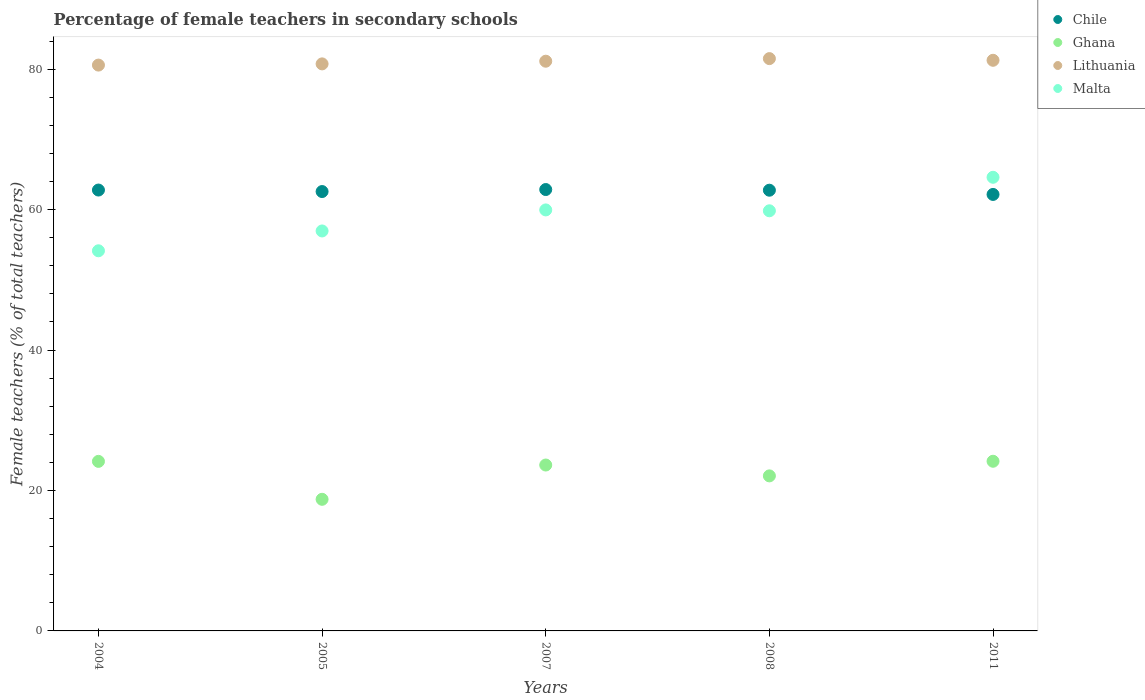How many different coloured dotlines are there?
Make the answer very short. 4. What is the percentage of female teachers in Chile in 2011?
Provide a short and direct response. 62.16. Across all years, what is the maximum percentage of female teachers in Malta?
Your answer should be very brief. 64.6. Across all years, what is the minimum percentage of female teachers in Malta?
Your response must be concise. 54.14. In which year was the percentage of female teachers in Lithuania maximum?
Keep it short and to the point. 2008. What is the total percentage of female teachers in Chile in the graph?
Offer a very short reply. 313.14. What is the difference between the percentage of female teachers in Malta in 2005 and that in 2008?
Your answer should be very brief. -2.87. What is the difference between the percentage of female teachers in Chile in 2005 and the percentage of female teachers in Lithuania in 2008?
Keep it short and to the point. -18.93. What is the average percentage of female teachers in Malta per year?
Make the answer very short. 59.1. In the year 2004, what is the difference between the percentage of female teachers in Ghana and percentage of female teachers in Lithuania?
Give a very brief answer. -56.43. What is the ratio of the percentage of female teachers in Lithuania in 2004 to that in 2008?
Your answer should be very brief. 0.99. Is the percentage of female teachers in Lithuania in 2004 less than that in 2007?
Provide a short and direct response. Yes. Is the difference between the percentage of female teachers in Ghana in 2007 and 2008 greater than the difference between the percentage of female teachers in Lithuania in 2007 and 2008?
Your answer should be compact. Yes. What is the difference between the highest and the second highest percentage of female teachers in Chile?
Provide a succinct answer. 0.07. What is the difference between the highest and the lowest percentage of female teachers in Chile?
Provide a succinct answer. 0.7. Is it the case that in every year, the sum of the percentage of female teachers in Malta and percentage of female teachers in Chile  is greater than the sum of percentage of female teachers in Ghana and percentage of female teachers in Lithuania?
Offer a very short reply. No. Is it the case that in every year, the sum of the percentage of female teachers in Chile and percentage of female teachers in Ghana  is greater than the percentage of female teachers in Lithuania?
Provide a succinct answer. Yes. Does the percentage of female teachers in Chile monotonically increase over the years?
Your answer should be compact. No. Is the percentage of female teachers in Chile strictly greater than the percentage of female teachers in Malta over the years?
Ensure brevity in your answer.  No. How many years are there in the graph?
Offer a very short reply. 5. Does the graph contain any zero values?
Offer a very short reply. No. Does the graph contain grids?
Offer a terse response. No. What is the title of the graph?
Keep it short and to the point. Percentage of female teachers in secondary schools. What is the label or title of the Y-axis?
Your answer should be compact. Female teachers (% of total teachers). What is the Female teachers (% of total teachers) in Chile in 2004?
Your response must be concise. 62.79. What is the Female teachers (% of total teachers) in Ghana in 2004?
Provide a succinct answer. 24.15. What is the Female teachers (% of total teachers) of Lithuania in 2004?
Keep it short and to the point. 80.58. What is the Female teachers (% of total teachers) of Malta in 2004?
Your answer should be compact. 54.14. What is the Female teachers (% of total teachers) of Chile in 2005?
Your response must be concise. 62.57. What is the Female teachers (% of total teachers) in Ghana in 2005?
Keep it short and to the point. 18.74. What is the Female teachers (% of total teachers) in Lithuania in 2005?
Your answer should be very brief. 80.75. What is the Female teachers (% of total teachers) of Malta in 2005?
Your response must be concise. 56.96. What is the Female teachers (% of total teachers) of Chile in 2007?
Ensure brevity in your answer.  62.86. What is the Female teachers (% of total teachers) in Ghana in 2007?
Provide a short and direct response. 23.63. What is the Female teachers (% of total teachers) in Lithuania in 2007?
Your answer should be compact. 81.13. What is the Female teachers (% of total teachers) of Malta in 2007?
Keep it short and to the point. 59.95. What is the Female teachers (% of total teachers) in Chile in 2008?
Give a very brief answer. 62.76. What is the Female teachers (% of total teachers) of Ghana in 2008?
Give a very brief answer. 22.08. What is the Female teachers (% of total teachers) of Lithuania in 2008?
Provide a succinct answer. 81.5. What is the Female teachers (% of total teachers) in Malta in 2008?
Provide a short and direct response. 59.83. What is the Female teachers (% of total teachers) of Chile in 2011?
Make the answer very short. 62.16. What is the Female teachers (% of total teachers) of Ghana in 2011?
Ensure brevity in your answer.  24.16. What is the Female teachers (% of total teachers) in Lithuania in 2011?
Your answer should be very brief. 81.26. What is the Female teachers (% of total teachers) in Malta in 2011?
Your response must be concise. 64.6. Across all years, what is the maximum Female teachers (% of total teachers) of Chile?
Offer a terse response. 62.86. Across all years, what is the maximum Female teachers (% of total teachers) in Ghana?
Provide a succinct answer. 24.16. Across all years, what is the maximum Female teachers (% of total teachers) in Lithuania?
Ensure brevity in your answer.  81.5. Across all years, what is the maximum Female teachers (% of total teachers) of Malta?
Your answer should be very brief. 64.6. Across all years, what is the minimum Female teachers (% of total teachers) in Chile?
Your response must be concise. 62.16. Across all years, what is the minimum Female teachers (% of total teachers) in Ghana?
Offer a very short reply. 18.74. Across all years, what is the minimum Female teachers (% of total teachers) of Lithuania?
Provide a succinct answer. 80.58. Across all years, what is the minimum Female teachers (% of total teachers) in Malta?
Ensure brevity in your answer.  54.14. What is the total Female teachers (% of total teachers) in Chile in the graph?
Make the answer very short. 313.14. What is the total Female teachers (% of total teachers) in Ghana in the graph?
Your answer should be compact. 112.76. What is the total Female teachers (% of total teachers) of Lithuania in the graph?
Provide a succinct answer. 405.23. What is the total Female teachers (% of total teachers) of Malta in the graph?
Provide a short and direct response. 295.48. What is the difference between the Female teachers (% of total teachers) in Chile in 2004 and that in 2005?
Provide a short and direct response. 0.21. What is the difference between the Female teachers (% of total teachers) in Ghana in 2004 and that in 2005?
Ensure brevity in your answer.  5.4. What is the difference between the Female teachers (% of total teachers) in Lithuania in 2004 and that in 2005?
Provide a short and direct response. -0.17. What is the difference between the Female teachers (% of total teachers) in Malta in 2004 and that in 2005?
Your answer should be compact. -2.82. What is the difference between the Female teachers (% of total teachers) in Chile in 2004 and that in 2007?
Your answer should be compact. -0.07. What is the difference between the Female teachers (% of total teachers) in Ghana in 2004 and that in 2007?
Offer a very short reply. 0.52. What is the difference between the Female teachers (% of total teachers) in Lithuania in 2004 and that in 2007?
Your response must be concise. -0.55. What is the difference between the Female teachers (% of total teachers) in Malta in 2004 and that in 2007?
Keep it short and to the point. -5.82. What is the difference between the Female teachers (% of total teachers) in Chile in 2004 and that in 2008?
Offer a terse response. 0.02. What is the difference between the Female teachers (% of total teachers) of Ghana in 2004 and that in 2008?
Provide a short and direct response. 2.07. What is the difference between the Female teachers (% of total teachers) of Lithuania in 2004 and that in 2008?
Provide a short and direct response. -0.92. What is the difference between the Female teachers (% of total teachers) of Malta in 2004 and that in 2008?
Make the answer very short. -5.7. What is the difference between the Female teachers (% of total teachers) in Chile in 2004 and that in 2011?
Give a very brief answer. 0.63. What is the difference between the Female teachers (% of total teachers) in Ghana in 2004 and that in 2011?
Provide a short and direct response. -0.02. What is the difference between the Female teachers (% of total teachers) of Lithuania in 2004 and that in 2011?
Your answer should be compact. -0.68. What is the difference between the Female teachers (% of total teachers) in Malta in 2004 and that in 2011?
Offer a very short reply. -10.47. What is the difference between the Female teachers (% of total teachers) in Chile in 2005 and that in 2007?
Your answer should be very brief. -0.29. What is the difference between the Female teachers (% of total teachers) in Ghana in 2005 and that in 2007?
Offer a terse response. -4.88. What is the difference between the Female teachers (% of total teachers) of Lithuania in 2005 and that in 2007?
Offer a terse response. -0.38. What is the difference between the Female teachers (% of total teachers) of Malta in 2005 and that in 2007?
Your response must be concise. -3. What is the difference between the Female teachers (% of total teachers) of Chile in 2005 and that in 2008?
Keep it short and to the point. -0.19. What is the difference between the Female teachers (% of total teachers) of Ghana in 2005 and that in 2008?
Your answer should be very brief. -3.34. What is the difference between the Female teachers (% of total teachers) of Lithuania in 2005 and that in 2008?
Keep it short and to the point. -0.75. What is the difference between the Female teachers (% of total teachers) in Malta in 2005 and that in 2008?
Make the answer very short. -2.87. What is the difference between the Female teachers (% of total teachers) of Chile in 2005 and that in 2011?
Offer a very short reply. 0.41. What is the difference between the Female teachers (% of total teachers) of Ghana in 2005 and that in 2011?
Make the answer very short. -5.42. What is the difference between the Female teachers (% of total teachers) of Lithuania in 2005 and that in 2011?
Your response must be concise. -0.51. What is the difference between the Female teachers (% of total teachers) of Malta in 2005 and that in 2011?
Offer a terse response. -7.64. What is the difference between the Female teachers (% of total teachers) of Chile in 2007 and that in 2008?
Keep it short and to the point. 0.1. What is the difference between the Female teachers (% of total teachers) in Ghana in 2007 and that in 2008?
Provide a short and direct response. 1.55. What is the difference between the Female teachers (% of total teachers) in Lithuania in 2007 and that in 2008?
Ensure brevity in your answer.  -0.37. What is the difference between the Female teachers (% of total teachers) in Malta in 2007 and that in 2008?
Ensure brevity in your answer.  0.12. What is the difference between the Female teachers (% of total teachers) of Chile in 2007 and that in 2011?
Give a very brief answer. 0.7. What is the difference between the Female teachers (% of total teachers) of Ghana in 2007 and that in 2011?
Your response must be concise. -0.54. What is the difference between the Female teachers (% of total teachers) of Lithuania in 2007 and that in 2011?
Your answer should be compact. -0.13. What is the difference between the Female teachers (% of total teachers) in Malta in 2007 and that in 2011?
Your answer should be compact. -4.65. What is the difference between the Female teachers (% of total teachers) in Chile in 2008 and that in 2011?
Keep it short and to the point. 0.6. What is the difference between the Female teachers (% of total teachers) in Ghana in 2008 and that in 2011?
Provide a short and direct response. -2.08. What is the difference between the Female teachers (% of total teachers) of Lithuania in 2008 and that in 2011?
Your response must be concise. 0.24. What is the difference between the Female teachers (% of total teachers) of Malta in 2008 and that in 2011?
Your response must be concise. -4.77. What is the difference between the Female teachers (% of total teachers) in Chile in 2004 and the Female teachers (% of total teachers) in Ghana in 2005?
Keep it short and to the point. 44.04. What is the difference between the Female teachers (% of total teachers) in Chile in 2004 and the Female teachers (% of total teachers) in Lithuania in 2005?
Your answer should be very brief. -17.97. What is the difference between the Female teachers (% of total teachers) of Chile in 2004 and the Female teachers (% of total teachers) of Malta in 2005?
Offer a terse response. 5.83. What is the difference between the Female teachers (% of total teachers) in Ghana in 2004 and the Female teachers (% of total teachers) in Lithuania in 2005?
Offer a very short reply. -56.61. What is the difference between the Female teachers (% of total teachers) of Ghana in 2004 and the Female teachers (% of total teachers) of Malta in 2005?
Give a very brief answer. -32.81. What is the difference between the Female teachers (% of total teachers) in Lithuania in 2004 and the Female teachers (% of total teachers) in Malta in 2005?
Give a very brief answer. 23.62. What is the difference between the Female teachers (% of total teachers) in Chile in 2004 and the Female teachers (% of total teachers) in Ghana in 2007?
Your answer should be compact. 39.16. What is the difference between the Female teachers (% of total teachers) of Chile in 2004 and the Female teachers (% of total teachers) of Lithuania in 2007?
Keep it short and to the point. -18.35. What is the difference between the Female teachers (% of total teachers) in Chile in 2004 and the Female teachers (% of total teachers) in Malta in 2007?
Ensure brevity in your answer.  2.83. What is the difference between the Female teachers (% of total teachers) of Ghana in 2004 and the Female teachers (% of total teachers) of Lithuania in 2007?
Keep it short and to the point. -56.99. What is the difference between the Female teachers (% of total teachers) in Ghana in 2004 and the Female teachers (% of total teachers) in Malta in 2007?
Offer a very short reply. -35.81. What is the difference between the Female teachers (% of total teachers) of Lithuania in 2004 and the Female teachers (% of total teachers) of Malta in 2007?
Make the answer very short. 20.63. What is the difference between the Female teachers (% of total teachers) in Chile in 2004 and the Female teachers (% of total teachers) in Ghana in 2008?
Ensure brevity in your answer.  40.71. What is the difference between the Female teachers (% of total teachers) in Chile in 2004 and the Female teachers (% of total teachers) in Lithuania in 2008?
Provide a succinct answer. -18.72. What is the difference between the Female teachers (% of total teachers) in Chile in 2004 and the Female teachers (% of total teachers) in Malta in 2008?
Your response must be concise. 2.95. What is the difference between the Female teachers (% of total teachers) in Ghana in 2004 and the Female teachers (% of total teachers) in Lithuania in 2008?
Your answer should be compact. -57.36. What is the difference between the Female teachers (% of total teachers) in Ghana in 2004 and the Female teachers (% of total teachers) in Malta in 2008?
Offer a very short reply. -35.69. What is the difference between the Female teachers (% of total teachers) of Lithuania in 2004 and the Female teachers (% of total teachers) of Malta in 2008?
Offer a very short reply. 20.75. What is the difference between the Female teachers (% of total teachers) of Chile in 2004 and the Female teachers (% of total teachers) of Ghana in 2011?
Provide a succinct answer. 38.62. What is the difference between the Female teachers (% of total teachers) in Chile in 2004 and the Female teachers (% of total teachers) in Lithuania in 2011?
Offer a terse response. -18.48. What is the difference between the Female teachers (% of total teachers) in Chile in 2004 and the Female teachers (% of total teachers) in Malta in 2011?
Provide a short and direct response. -1.82. What is the difference between the Female teachers (% of total teachers) of Ghana in 2004 and the Female teachers (% of total teachers) of Lithuania in 2011?
Make the answer very short. -57.12. What is the difference between the Female teachers (% of total teachers) in Ghana in 2004 and the Female teachers (% of total teachers) in Malta in 2011?
Ensure brevity in your answer.  -40.46. What is the difference between the Female teachers (% of total teachers) in Lithuania in 2004 and the Female teachers (% of total teachers) in Malta in 2011?
Offer a terse response. 15.98. What is the difference between the Female teachers (% of total teachers) in Chile in 2005 and the Female teachers (% of total teachers) in Ghana in 2007?
Your answer should be compact. 38.95. What is the difference between the Female teachers (% of total teachers) in Chile in 2005 and the Female teachers (% of total teachers) in Lithuania in 2007?
Keep it short and to the point. -18.56. What is the difference between the Female teachers (% of total teachers) of Chile in 2005 and the Female teachers (% of total teachers) of Malta in 2007?
Keep it short and to the point. 2.62. What is the difference between the Female teachers (% of total teachers) in Ghana in 2005 and the Female teachers (% of total teachers) in Lithuania in 2007?
Provide a short and direct response. -62.39. What is the difference between the Female teachers (% of total teachers) in Ghana in 2005 and the Female teachers (% of total teachers) in Malta in 2007?
Offer a very short reply. -41.21. What is the difference between the Female teachers (% of total teachers) of Lithuania in 2005 and the Female teachers (% of total teachers) of Malta in 2007?
Give a very brief answer. 20.8. What is the difference between the Female teachers (% of total teachers) in Chile in 2005 and the Female teachers (% of total teachers) in Ghana in 2008?
Make the answer very short. 40.49. What is the difference between the Female teachers (% of total teachers) in Chile in 2005 and the Female teachers (% of total teachers) in Lithuania in 2008?
Provide a succinct answer. -18.93. What is the difference between the Female teachers (% of total teachers) of Chile in 2005 and the Female teachers (% of total teachers) of Malta in 2008?
Offer a terse response. 2.74. What is the difference between the Female teachers (% of total teachers) of Ghana in 2005 and the Female teachers (% of total teachers) of Lithuania in 2008?
Ensure brevity in your answer.  -62.76. What is the difference between the Female teachers (% of total teachers) of Ghana in 2005 and the Female teachers (% of total teachers) of Malta in 2008?
Give a very brief answer. -41.09. What is the difference between the Female teachers (% of total teachers) of Lithuania in 2005 and the Female teachers (% of total teachers) of Malta in 2008?
Your response must be concise. 20.92. What is the difference between the Female teachers (% of total teachers) of Chile in 2005 and the Female teachers (% of total teachers) of Ghana in 2011?
Ensure brevity in your answer.  38.41. What is the difference between the Female teachers (% of total teachers) of Chile in 2005 and the Female teachers (% of total teachers) of Lithuania in 2011?
Make the answer very short. -18.69. What is the difference between the Female teachers (% of total teachers) of Chile in 2005 and the Female teachers (% of total teachers) of Malta in 2011?
Ensure brevity in your answer.  -2.03. What is the difference between the Female teachers (% of total teachers) of Ghana in 2005 and the Female teachers (% of total teachers) of Lithuania in 2011?
Make the answer very short. -62.52. What is the difference between the Female teachers (% of total teachers) in Ghana in 2005 and the Female teachers (% of total teachers) in Malta in 2011?
Offer a very short reply. -45.86. What is the difference between the Female teachers (% of total teachers) in Lithuania in 2005 and the Female teachers (% of total teachers) in Malta in 2011?
Keep it short and to the point. 16.15. What is the difference between the Female teachers (% of total teachers) of Chile in 2007 and the Female teachers (% of total teachers) of Ghana in 2008?
Your response must be concise. 40.78. What is the difference between the Female teachers (% of total teachers) of Chile in 2007 and the Female teachers (% of total teachers) of Lithuania in 2008?
Your response must be concise. -18.65. What is the difference between the Female teachers (% of total teachers) of Chile in 2007 and the Female teachers (% of total teachers) of Malta in 2008?
Keep it short and to the point. 3.03. What is the difference between the Female teachers (% of total teachers) of Ghana in 2007 and the Female teachers (% of total teachers) of Lithuania in 2008?
Your answer should be compact. -57.88. What is the difference between the Female teachers (% of total teachers) in Ghana in 2007 and the Female teachers (% of total teachers) in Malta in 2008?
Your answer should be compact. -36.21. What is the difference between the Female teachers (% of total teachers) in Lithuania in 2007 and the Female teachers (% of total teachers) in Malta in 2008?
Your response must be concise. 21.3. What is the difference between the Female teachers (% of total teachers) in Chile in 2007 and the Female teachers (% of total teachers) in Ghana in 2011?
Your answer should be compact. 38.7. What is the difference between the Female teachers (% of total teachers) of Chile in 2007 and the Female teachers (% of total teachers) of Lithuania in 2011?
Offer a terse response. -18.41. What is the difference between the Female teachers (% of total teachers) in Chile in 2007 and the Female teachers (% of total teachers) in Malta in 2011?
Your answer should be compact. -1.75. What is the difference between the Female teachers (% of total teachers) of Ghana in 2007 and the Female teachers (% of total teachers) of Lithuania in 2011?
Your answer should be very brief. -57.64. What is the difference between the Female teachers (% of total teachers) in Ghana in 2007 and the Female teachers (% of total teachers) in Malta in 2011?
Offer a very short reply. -40.98. What is the difference between the Female teachers (% of total teachers) of Lithuania in 2007 and the Female teachers (% of total teachers) of Malta in 2011?
Offer a terse response. 16.53. What is the difference between the Female teachers (% of total teachers) in Chile in 2008 and the Female teachers (% of total teachers) in Ghana in 2011?
Keep it short and to the point. 38.6. What is the difference between the Female teachers (% of total teachers) in Chile in 2008 and the Female teachers (% of total teachers) in Lithuania in 2011?
Make the answer very short. -18.5. What is the difference between the Female teachers (% of total teachers) of Chile in 2008 and the Female teachers (% of total teachers) of Malta in 2011?
Ensure brevity in your answer.  -1.84. What is the difference between the Female teachers (% of total teachers) of Ghana in 2008 and the Female teachers (% of total teachers) of Lithuania in 2011?
Your answer should be compact. -59.18. What is the difference between the Female teachers (% of total teachers) of Ghana in 2008 and the Female teachers (% of total teachers) of Malta in 2011?
Offer a very short reply. -42.52. What is the difference between the Female teachers (% of total teachers) in Lithuania in 2008 and the Female teachers (% of total teachers) in Malta in 2011?
Offer a very short reply. 16.9. What is the average Female teachers (% of total teachers) of Chile per year?
Make the answer very short. 62.63. What is the average Female teachers (% of total teachers) of Ghana per year?
Your answer should be compact. 22.55. What is the average Female teachers (% of total teachers) in Lithuania per year?
Offer a terse response. 81.05. What is the average Female teachers (% of total teachers) of Malta per year?
Your answer should be compact. 59.1. In the year 2004, what is the difference between the Female teachers (% of total teachers) of Chile and Female teachers (% of total teachers) of Ghana?
Ensure brevity in your answer.  38.64. In the year 2004, what is the difference between the Female teachers (% of total teachers) in Chile and Female teachers (% of total teachers) in Lithuania?
Offer a very short reply. -17.8. In the year 2004, what is the difference between the Female teachers (% of total teachers) of Chile and Female teachers (% of total teachers) of Malta?
Your response must be concise. 8.65. In the year 2004, what is the difference between the Female teachers (% of total teachers) in Ghana and Female teachers (% of total teachers) in Lithuania?
Your answer should be compact. -56.43. In the year 2004, what is the difference between the Female teachers (% of total teachers) of Ghana and Female teachers (% of total teachers) of Malta?
Your response must be concise. -29.99. In the year 2004, what is the difference between the Female teachers (% of total teachers) of Lithuania and Female teachers (% of total teachers) of Malta?
Keep it short and to the point. 26.45. In the year 2005, what is the difference between the Female teachers (% of total teachers) of Chile and Female teachers (% of total teachers) of Ghana?
Ensure brevity in your answer.  43.83. In the year 2005, what is the difference between the Female teachers (% of total teachers) of Chile and Female teachers (% of total teachers) of Lithuania?
Your response must be concise. -18.18. In the year 2005, what is the difference between the Female teachers (% of total teachers) of Chile and Female teachers (% of total teachers) of Malta?
Your answer should be compact. 5.61. In the year 2005, what is the difference between the Female teachers (% of total teachers) in Ghana and Female teachers (% of total teachers) in Lithuania?
Provide a succinct answer. -62.01. In the year 2005, what is the difference between the Female teachers (% of total teachers) of Ghana and Female teachers (% of total teachers) of Malta?
Your response must be concise. -38.22. In the year 2005, what is the difference between the Female teachers (% of total teachers) of Lithuania and Female teachers (% of total teachers) of Malta?
Provide a succinct answer. 23.79. In the year 2007, what is the difference between the Female teachers (% of total teachers) in Chile and Female teachers (% of total teachers) in Ghana?
Make the answer very short. 39.23. In the year 2007, what is the difference between the Female teachers (% of total teachers) of Chile and Female teachers (% of total teachers) of Lithuania?
Your answer should be compact. -18.28. In the year 2007, what is the difference between the Female teachers (% of total teachers) in Chile and Female teachers (% of total teachers) in Malta?
Make the answer very short. 2.9. In the year 2007, what is the difference between the Female teachers (% of total teachers) of Ghana and Female teachers (% of total teachers) of Lithuania?
Keep it short and to the point. -57.51. In the year 2007, what is the difference between the Female teachers (% of total teachers) of Ghana and Female teachers (% of total teachers) of Malta?
Make the answer very short. -36.33. In the year 2007, what is the difference between the Female teachers (% of total teachers) in Lithuania and Female teachers (% of total teachers) in Malta?
Your answer should be compact. 21.18. In the year 2008, what is the difference between the Female teachers (% of total teachers) in Chile and Female teachers (% of total teachers) in Ghana?
Offer a very short reply. 40.68. In the year 2008, what is the difference between the Female teachers (% of total teachers) of Chile and Female teachers (% of total teachers) of Lithuania?
Make the answer very short. -18.74. In the year 2008, what is the difference between the Female teachers (% of total teachers) in Chile and Female teachers (% of total teachers) in Malta?
Ensure brevity in your answer.  2.93. In the year 2008, what is the difference between the Female teachers (% of total teachers) in Ghana and Female teachers (% of total teachers) in Lithuania?
Offer a very short reply. -59.42. In the year 2008, what is the difference between the Female teachers (% of total teachers) in Ghana and Female teachers (% of total teachers) in Malta?
Provide a short and direct response. -37.75. In the year 2008, what is the difference between the Female teachers (% of total teachers) of Lithuania and Female teachers (% of total teachers) of Malta?
Offer a very short reply. 21.67. In the year 2011, what is the difference between the Female teachers (% of total teachers) in Chile and Female teachers (% of total teachers) in Ghana?
Your response must be concise. 38. In the year 2011, what is the difference between the Female teachers (% of total teachers) in Chile and Female teachers (% of total teachers) in Lithuania?
Provide a succinct answer. -19.1. In the year 2011, what is the difference between the Female teachers (% of total teachers) of Chile and Female teachers (% of total teachers) of Malta?
Provide a succinct answer. -2.44. In the year 2011, what is the difference between the Female teachers (% of total teachers) in Ghana and Female teachers (% of total teachers) in Lithuania?
Your answer should be very brief. -57.1. In the year 2011, what is the difference between the Female teachers (% of total teachers) in Ghana and Female teachers (% of total teachers) in Malta?
Make the answer very short. -40.44. In the year 2011, what is the difference between the Female teachers (% of total teachers) in Lithuania and Female teachers (% of total teachers) in Malta?
Offer a terse response. 16.66. What is the ratio of the Female teachers (% of total teachers) of Chile in 2004 to that in 2005?
Ensure brevity in your answer.  1. What is the ratio of the Female teachers (% of total teachers) in Ghana in 2004 to that in 2005?
Offer a very short reply. 1.29. What is the ratio of the Female teachers (% of total teachers) of Lithuania in 2004 to that in 2005?
Give a very brief answer. 1. What is the ratio of the Female teachers (% of total teachers) in Malta in 2004 to that in 2005?
Ensure brevity in your answer.  0.95. What is the ratio of the Female teachers (% of total teachers) in Malta in 2004 to that in 2007?
Give a very brief answer. 0.9. What is the ratio of the Female teachers (% of total teachers) in Chile in 2004 to that in 2008?
Keep it short and to the point. 1. What is the ratio of the Female teachers (% of total teachers) in Ghana in 2004 to that in 2008?
Your response must be concise. 1.09. What is the ratio of the Female teachers (% of total teachers) of Lithuania in 2004 to that in 2008?
Your answer should be compact. 0.99. What is the ratio of the Female teachers (% of total teachers) of Malta in 2004 to that in 2008?
Your answer should be compact. 0.9. What is the ratio of the Female teachers (% of total teachers) in Malta in 2004 to that in 2011?
Offer a very short reply. 0.84. What is the ratio of the Female teachers (% of total teachers) in Ghana in 2005 to that in 2007?
Your answer should be very brief. 0.79. What is the ratio of the Female teachers (% of total teachers) in Lithuania in 2005 to that in 2007?
Offer a very short reply. 1. What is the ratio of the Female teachers (% of total teachers) in Chile in 2005 to that in 2008?
Your answer should be compact. 1. What is the ratio of the Female teachers (% of total teachers) in Ghana in 2005 to that in 2008?
Your answer should be compact. 0.85. What is the ratio of the Female teachers (% of total teachers) in Lithuania in 2005 to that in 2008?
Offer a very short reply. 0.99. What is the ratio of the Female teachers (% of total teachers) in Chile in 2005 to that in 2011?
Make the answer very short. 1.01. What is the ratio of the Female teachers (% of total teachers) in Ghana in 2005 to that in 2011?
Your response must be concise. 0.78. What is the ratio of the Female teachers (% of total teachers) in Lithuania in 2005 to that in 2011?
Offer a terse response. 0.99. What is the ratio of the Female teachers (% of total teachers) in Malta in 2005 to that in 2011?
Give a very brief answer. 0.88. What is the ratio of the Female teachers (% of total teachers) in Chile in 2007 to that in 2008?
Your response must be concise. 1. What is the ratio of the Female teachers (% of total teachers) in Ghana in 2007 to that in 2008?
Give a very brief answer. 1.07. What is the ratio of the Female teachers (% of total teachers) of Lithuania in 2007 to that in 2008?
Offer a terse response. 1. What is the ratio of the Female teachers (% of total teachers) of Malta in 2007 to that in 2008?
Provide a short and direct response. 1. What is the ratio of the Female teachers (% of total teachers) of Chile in 2007 to that in 2011?
Make the answer very short. 1.01. What is the ratio of the Female teachers (% of total teachers) of Ghana in 2007 to that in 2011?
Your answer should be very brief. 0.98. What is the ratio of the Female teachers (% of total teachers) in Malta in 2007 to that in 2011?
Your response must be concise. 0.93. What is the ratio of the Female teachers (% of total teachers) of Chile in 2008 to that in 2011?
Your answer should be very brief. 1.01. What is the ratio of the Female teachers (% of total teachers) in Ghana in 2008 to that in 2011?
Provide a succinct answer. 0.91. What is the ratio of the Female teachers (% of total teachers) of Malta in 2008 to that in 2011?
Ensure brevity in your answer.  0.93. What is the difference between the highest and the second highest Female teachers (% of total teachers) in Chile?
Provide a short and direct response. 0.07. What is the difference between the highest and the second highest Female teachers (% of total teachers) of Ghana?
Your response must be concise. 0.02. What is the difference between the highest and the second highest Female teachers (% of total teachers) in Lithuania?
Keep it short and to the point. 0.24. What is the difference between the highest and the second highest Female teachers (% of total teachers) of Malta?
Your response must be concise. 4.65. What is the difference between the highest and the lowest Female teachers (% of total teachers) in Chile?
Give a very brief answer. 0.7. What is the difference between the highest and the lowest Female teachers (% of total teachers) in Ghana?
Offer a terse response. 5.42. What is the difference between the highest and the lowest Female teachers (% of total teachers) of Lithuania?
Ensure brevity in your answer.  0.92. What is the difference between the highest and the lowest Female teachers (% of total teachers) of Malta?
Offer a very short reply. 10.47. 